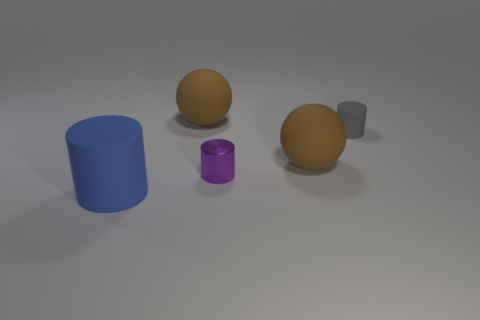Subtract all rubber cylinders. How many cylinders are left? 1 Add 5 gray cylinders. How many objects exist? 10 Subtract all balls. How many objects are left? 3 Add 2 small brown shiny cubes. How many small brown shiny cubes exist? 2 Subtract 0 brown blocks. How many objects are left? 5 Subtract all large matte spheres. Subtract all big cylinders. How many objects are left? 2 Add 2 large rubber cylinders. How many large rubber cylinders are left? 3 